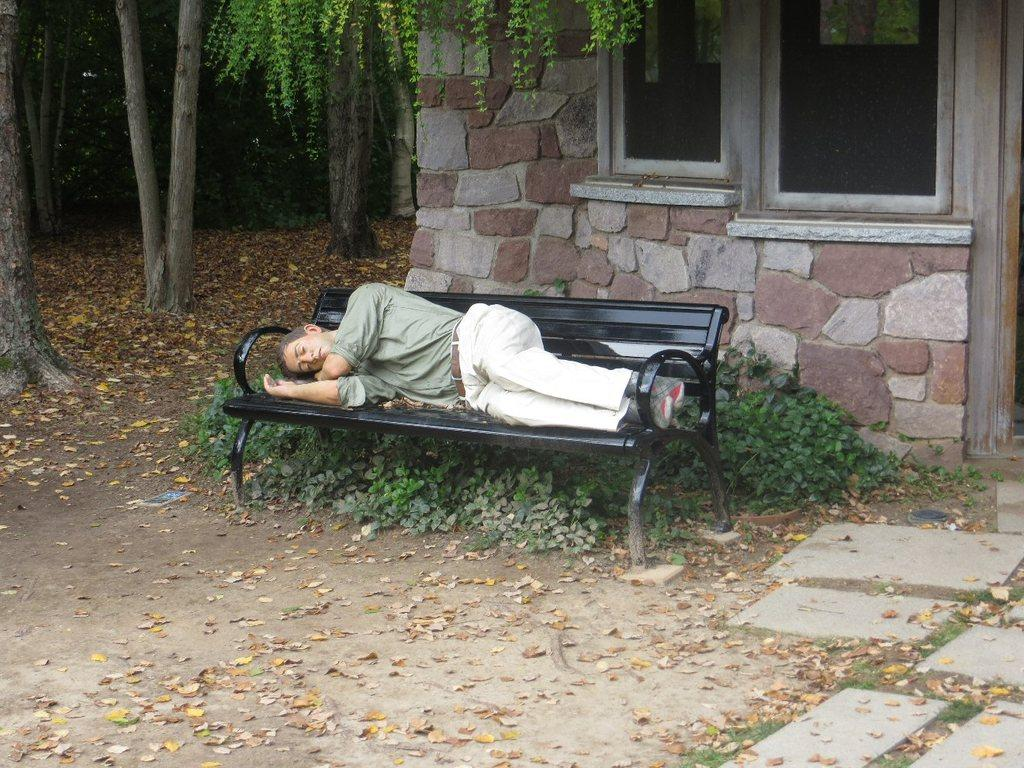What type of structure is present in the image? There is a house in the image. What feature of the house can be seen in the image? The house has windows. What type of natural elements are visible in the image? There are trees and plants in the image. What is the person in the image doing? There is a person laying on a bench in the image. What type of story is being told by the silk and hammer in the image? There is no silk or hammer present in the image, so no such story can be observed. 